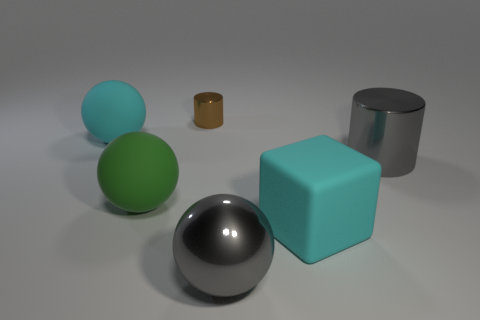Is there a blue shiny thing of the same shape as the brown metallic object?
Provide a short and direct response. No. How many objects are cyan matte objects that are on the left side of the large cyan block or cylinders?
Provide a succinct answer. 3. Are there more green matte things than big green matte cubes?
Provide a succinct answer. Yes. Are there any green matte things that have the same size as the matte cube?
Ensure brevity in your answer.  Yes. How many things are either balls that are behind the gray ball or gray things in front of the green rubber object?
Your answer should be very brief. 3. The cylinder behind the big cyan object that is on the left side of the matte cube is what color?
Your response must be concise. Brown. What color is the big cylinder that is the same material as the tiny cylinder?
Offer a very short reply. Gray. How many big cylinders are the same color as the block?
Provide a short and direct response. 0. How many objects are either tiny brown metallic cylinders or green metal cylinders?
Your response must be concise. 1. What shape is the cyan thing that is the same size as the block?
Ensure brevity in your answer.  Sphere. 